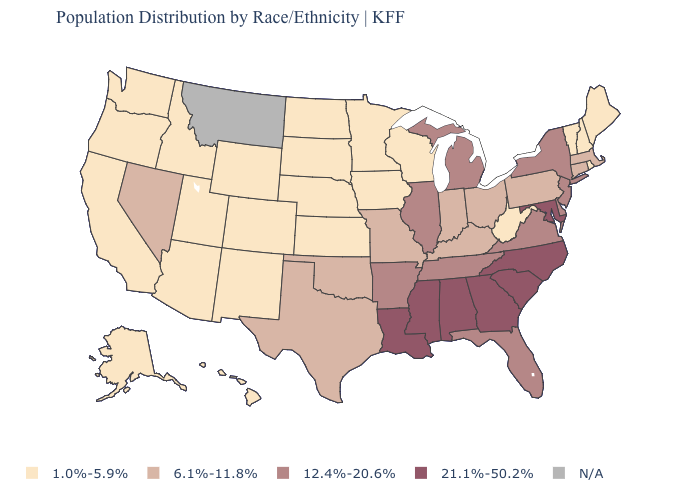How many symbols are there in the legend?
Be succinct. 5. What is the lowest value in the USA?
Quick response, please. 1.0%-5.9%. Among the states that border Oklahoma , which have the lowest value?
Answer briefly. Colorado, Kansas, New Mexico. Is the legend a continuous bar?
Quick response, please. No. What is the lowest value in the USA?
Answer briefly. 1.0%-5.9%. Name the states that have a value in the range 6.1%-11.8%?
Quick response, please. Connecticut, Indiana, Kentucky, Massachusetts, Missouri, Nevada, Ohio, Oklahoma, Pennsylvania, Texas. What is the highest value in the USA?
Give a very brief answer. 21.1%-50.2%. Among the states that border Oklahoma , does Colorado have the lowest value?
Be succinct. Yes. What is the value of Nebraska?
Answer briefly. 1.0%-5.9%. What is the lowest value in the South?
Quick response, please. 1.0%-5.9%. Does the map have missing data?
Quick response, please. Yes. Does the map have missing data?
Short answer required. Yes. Which states have the lowest value in the Northeast?
Quick response, please. Maine, New Hampshire, Rhode Island, Vermont. What is the lowest value in states that border Michigan?
Write a very short answer. 1.0%-5.9%. What is the lowest value in the Northeast?
Be succinct. 1.0%-5.9%. 